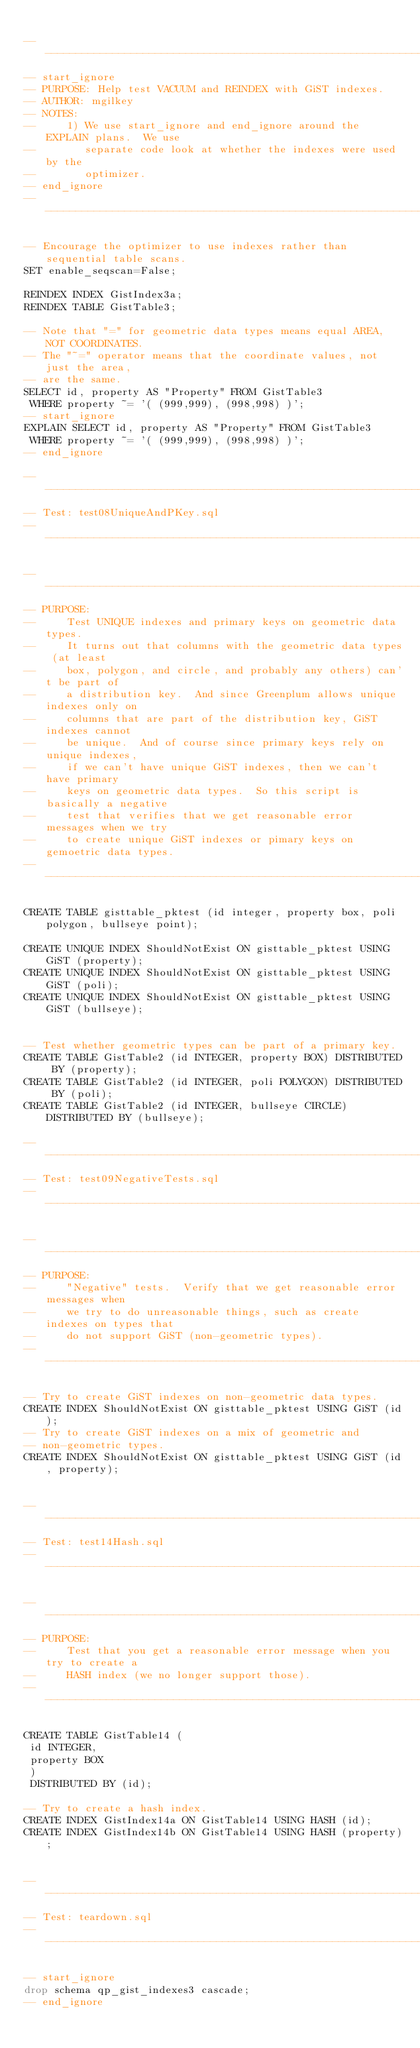<code> <loc_0><loc_0><loc_500><loc_500><_SQL_>
------------------------------------------------------------------------------
-- start_ignore
-- PURPOSE: Help test VACUUM and REINDEX with GiST indexes. 
-- AUTHOR: mgilkey
-- NOTES:
--     1) We use start_ignore and end_ignore around the EXPLAIN plans.  We use 
--        separate code look at whether the indexes were used by the 
--        optimizer.
-- end_ignore
------------------------------------------------------------------------------

-- Encourage the optimizer to use indexes rather than sequential table scans.
SET enable_seqscan=False;

REINDEX INDEX GistIndex3a;
REINDEX TABLE GistTable3;

-- Note that "=" for geometric data types means equal AREA, NOT COORDINATES.
-- The "~=" operator means that the coordinate values, not just the area,
-- are the same.
SELECT id, property AS "Property" FROM GistTable3
 WHERE property ~= '( (999,999), (998,998) )';
-- start_ignore
EXPLAIN SELECT id, property AS "Property" FROM GistTable3
 WHERE property ~= '( (999,999), (998,998) )';
-- end_ignore

-- ----------------------------------------------------------------------
-- Test: test08UniqueAndPKey.sql
-- ----------------------------------------------------------------------

------------------------------------------------------------------------------
-- PURPOSE:
--     Test UNIQUE indexes and primary keys on geometric data types.
--     It turns out that columns with the geometric data types (at least
--     box, polygon, and circle, and probably any others) can't be part of
--     a distribution key.  And since Greenplum allows unique indexes only on
--     columns that are part of the distribution key, GiST indexes cannot
--     be unique.  And of course since primary keys rely on unique indexes,
--     if we can't have unique GiST indexes, then we can't have primary
--     keys on geometric data types.  So this script is basically a negative
--     test that verifies that we get reasonable error messages when we try
--     to create unique GiST indexes or pimary keys on gemoetric data types.
------------------------------------------------------------------------------

CREATE TABLE gisttable_pktest (id integer, property box, poli polygon, bullseye point);

CREATE UNIQUE INDEX ShouldNotExist ON gisttable_pktest USING GiST (property);
CREATE UNIQUE INDEX ShouldNotExist ON gisttable_pktest USING GiST (poli);
CREATE UNIQUE INDEX ShouldNotExist ON gisttable_pktest USING GiST (bullseye);


-- Test whether geometric types can be part of a primary key.
CREATE TABLE GistTable2 (id INTEGER, property BOX) DISTRIBUTED BY (property);
CREATE TABLE GistTable2 (id INTEGER, poli POLYGON) DISTRIBUTED BY (poli);
CREATE TABLE GistTable2 (id INTEGER, bullseye CIRCLE) DISTRIBUTED BY (bullseye);

-- ----------------------------------------------------------------------
-- Test: test09NegativeTests.sql
-- ----------------------------------------------------------------------

------------------------------------------------------------------------------
-- PURPOSE:
--     "Negative" tests.  Verify that we get reasonable error messages when
--     we try to do unreasonable things, such as create indexes on types that
--     do not support GiST (non-geometric types).
------------------------------------------------------------------------------

-- Try to create GiST indexes on non-geometric data types.
CREATE INDEX ShouldNotExist ON gisttable_pktest USING GiST (id);
-- Try to create GiST indexes on a mix of geometric and
-- non-geometric types.
CREATE INDEX ShouldNotExist ON gisttable_pktest USING GiST (id, property);


-- ----------------------------------------------------------------------
-- Test: test14Hash.sql
-- ----------------------------------------------------------------------

------------------------------------------------------------------------------
-- PURPOSE:
--     Test that you get a reasonable error message when you try to create a
--     HASH index (we no longer support those).
------------------------------------------------------------------------------

CREATE TABLE GistTable14 (
 id INTEGER,
 property BOX
 )
 DISTRIBUTED BY (id);

-- Try to create a hash index.
CREATE INDEX GistIndex14a ON GistTable14 USING HASH (id);
CREATE INDEX GistIndex14b ON GistTable14 USING HASH (property);


-- ----------------------------------------------------------------------
-- Test: teardown.sql
-- ----------------------------------------------------------------------

-- start_ignore
drop schema qp_gist_indexes3 cascade;
-- end_ignore
</code> 